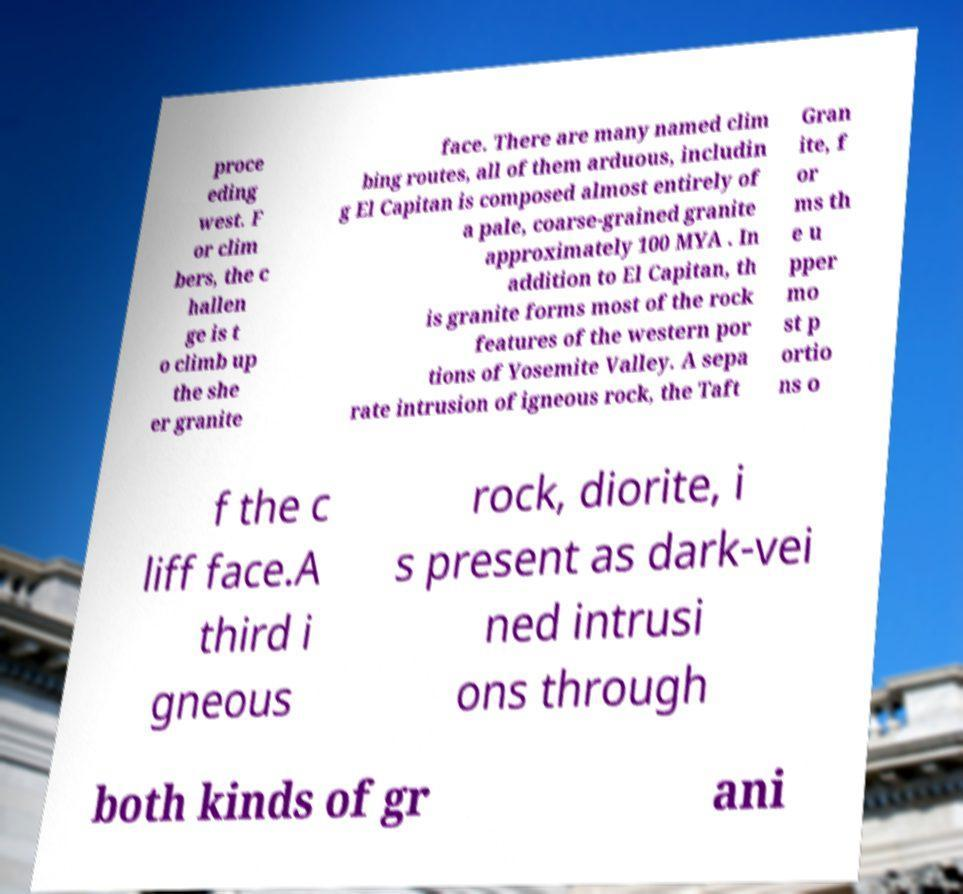There's text embedded in this image that I need extracted. Can you transcribe it verbatim? proce eding west. F or clim bers, the c hallen ge is t o climb up the she er granite face. There are many named clim bing routes, all of them arduous, includin g El Capitan is composed almost entirely of a pale, coarse-grained granite approximately 100 MYA . In addition to El Capitan, th is granite forms most of the rock features of the western por tions of Yosemite Valley. A sepa rate intrusion of igneous rock, the Taft Gran ite, f or ms th e u pper mo st p ortio ns o f the c liff face.A third i gneous rock, diorite, i s present as dark-vei ned intrusi ons through both kinds of gr ani 